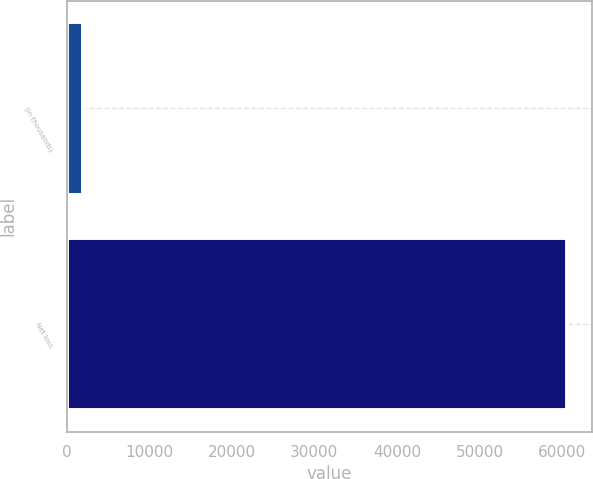Convert chart. <chart><loc_0><loc_0><loc_500><loc_500><bar_chart><fcel>(in thousands)<fcel>Net loss<nl><fcel>2009<fcel>60604<nl></chart> 